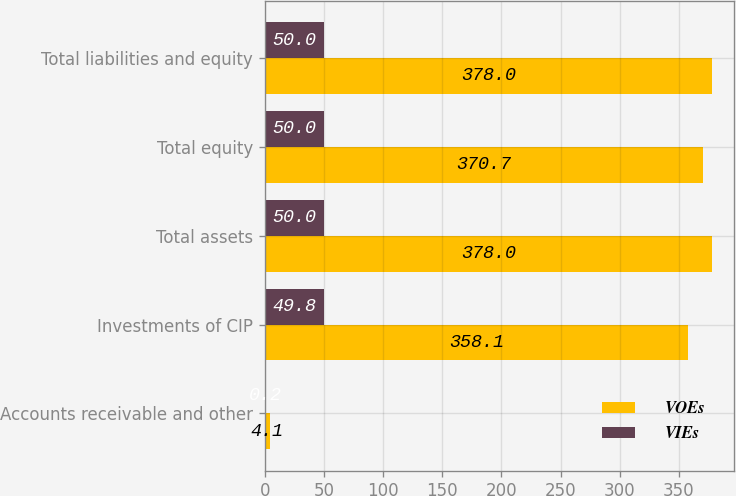Convert chart. <chart><loc_0><loc_0><loc_500><loc_500><stacked_bar_chart><ecel><fcel>Accounts receivable and other<fcel>Investments of CIP<fcel>Total assets<fcel>Total equity<fcel>Total liabilities and equity<nl><fcel>VOEs<fcel>4.1<fcel>358.1<fcel>378<fcel>370.7<fcel>378<nl><fcel>VIEs<fcel>0.2<fcel>49.8<fcel>50<fcel>50<fcel>50<nl></chart> 